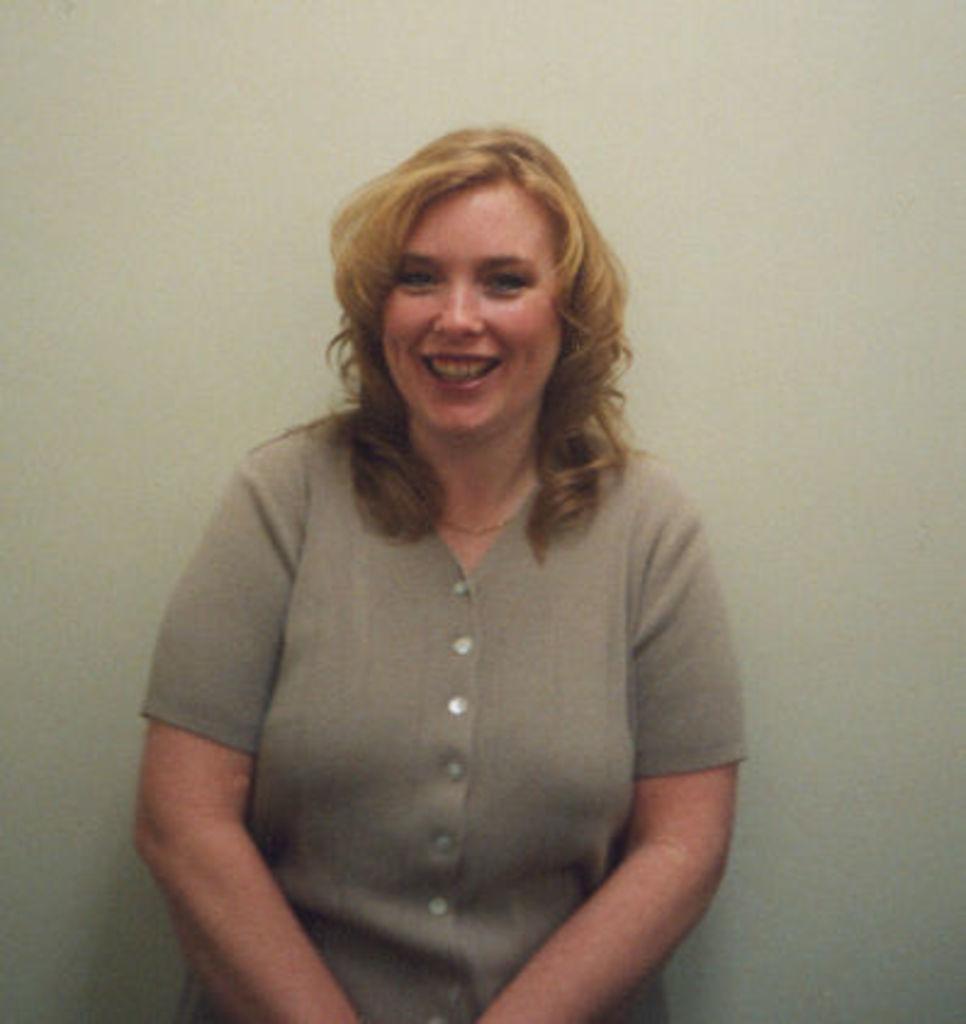How would you summarize this image in a sentence or two? Here I can see a woman standing, smiling and giving pose for the picture. At the back of her there is a wall. 